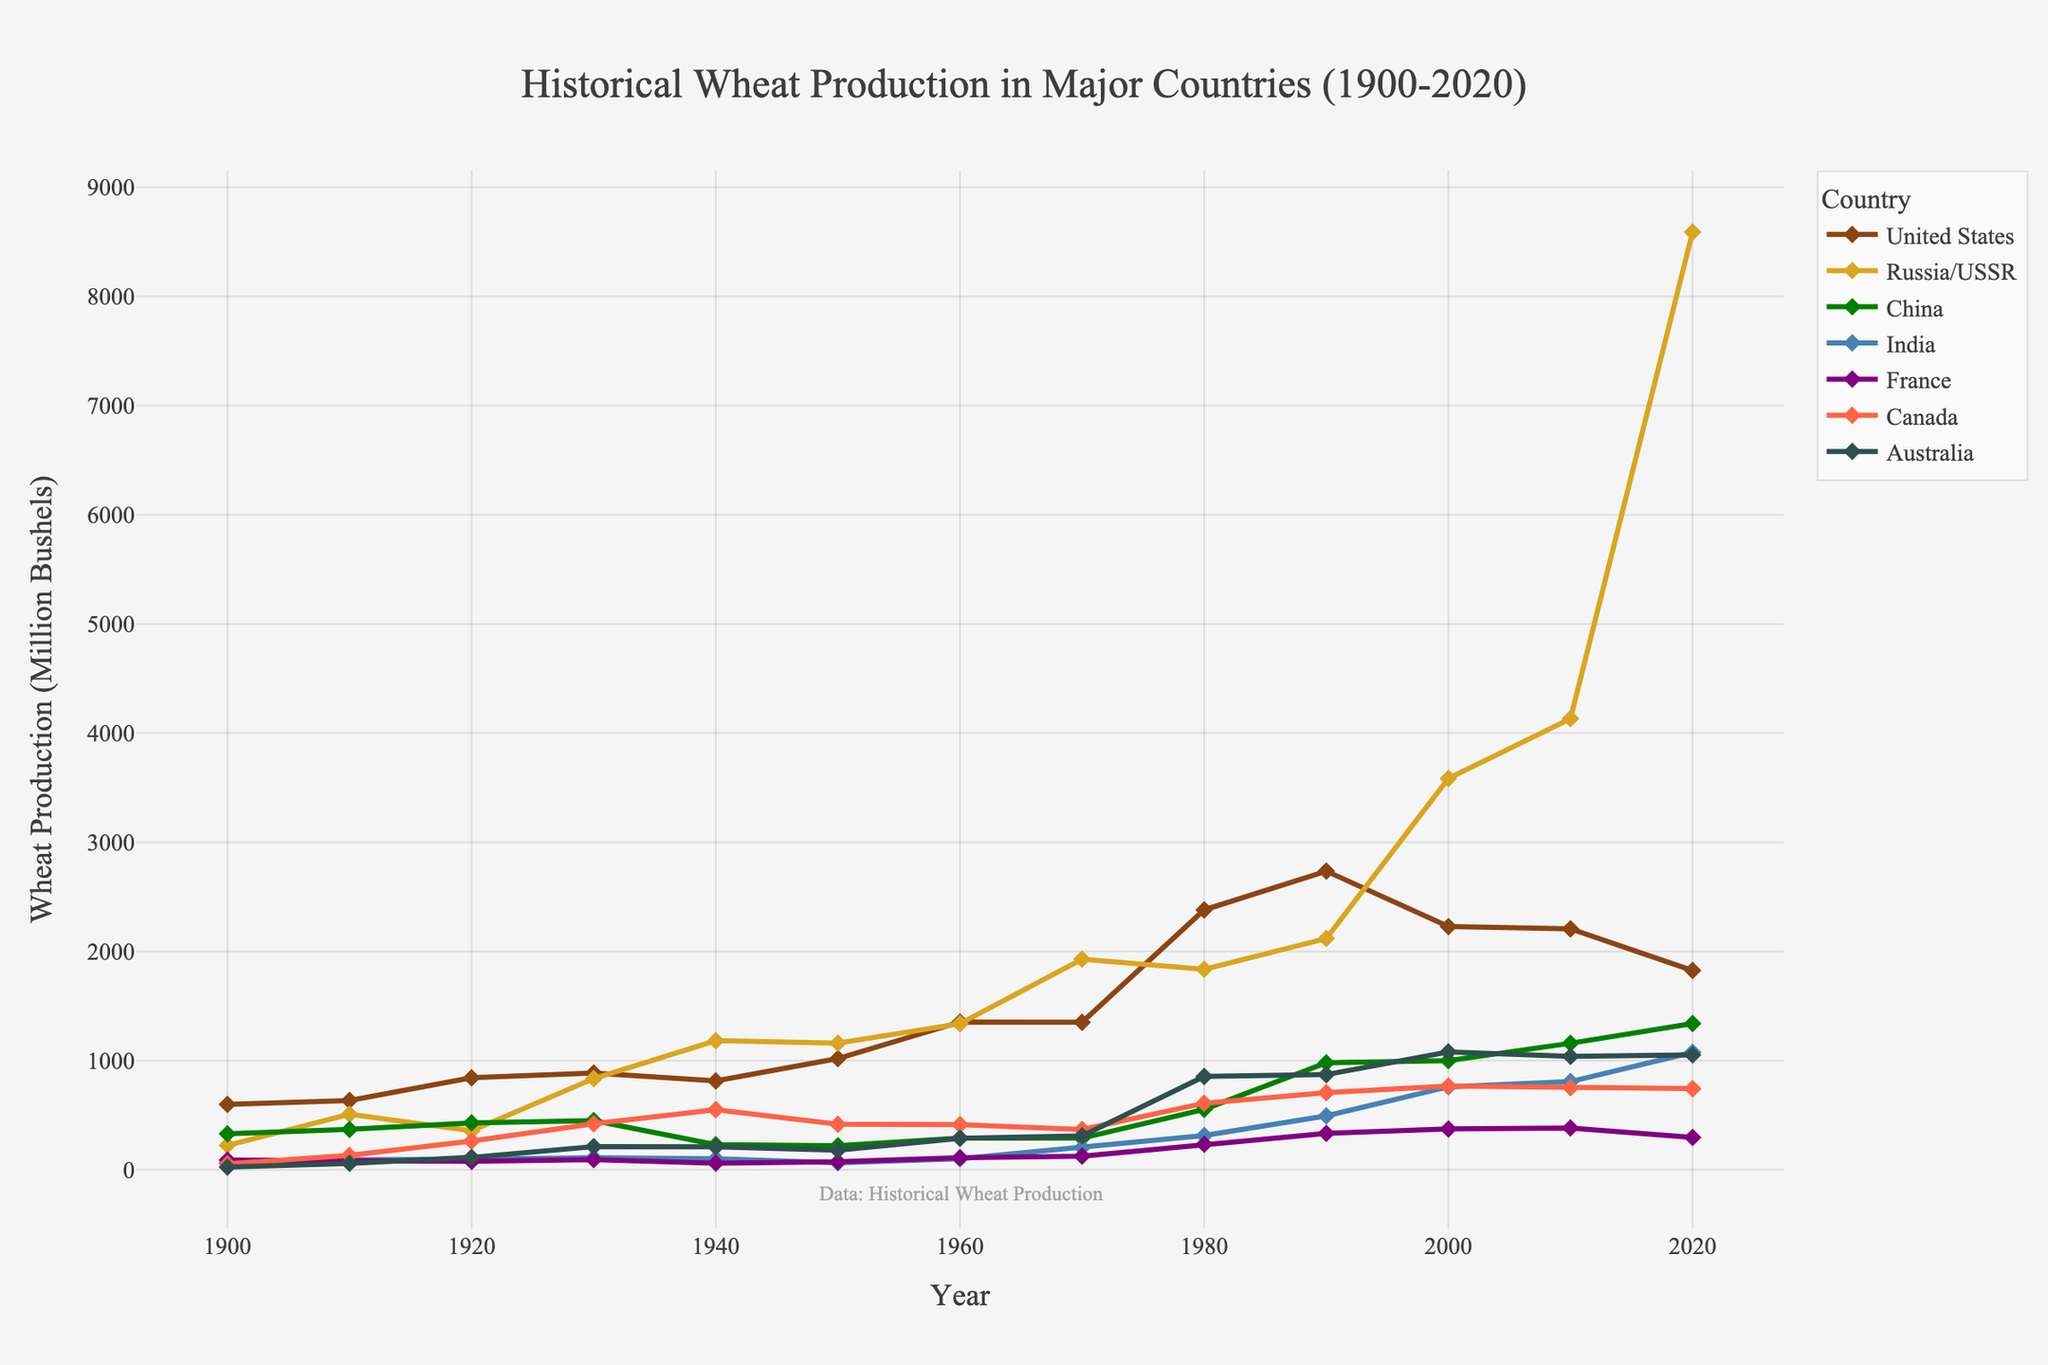- Which country had the highest wheat production in 2020? The figure shows the wheat production trends over the years. In 2020, by looking at the height of the lines, Russia/USSR's line reaches the highest value.
Answer: Russia/USSR - By how much did the United States' wheat production decrease from 1980 to 2020? The figure indicates that in 1980, the United States' wheat production was around 2381 million bushels, and in 2020, it was around 1826 million bushels. The difference can be calculated as 2381 - 1826.
Answer: 555 million bushels - Which country doubled its wheat production between 2000 and 2020? Referring to the chart, India’s production grows from around 760 million bushels in 2000 to around 1076 million bushels in 2020, clearly doubling the amount.
Answer: India - What was the production trend for China from 1900 to 2020? Observing the plot for China, its production started at 330 million bushels in 1900 and gradually increased to reach around 1340 million bushels by 2020, indicating an overall upward trend.
Answer: Upward trend - Comparing France and Canada, which country had higher wheat production in 1960? By examining the figure, in 1960, the production of France is represented by a shorter line in comparison to Canada’s line. Thus, Canada had higher production.
Answer: Canada - What was the average wheat production of France over the entire period? Summing all the given values for France (89, 87, 78, 94, 61, 73, 110, 125, 234, 333, 374, 383, 297) and dividing by the number of points (13 years), the average is (1774 / 13).
Answer: ~136 million bushels - How did Australia’s production in 1980 compare to that in 1970? According to the figure, Australia's production appeared to have more than doubled from 311 million bushels in 1970 to 855 million bushels in 1980.
Answer: It more than doubled - Which decade saw the highest increase in wheat production for the United States? From examining the chart, the steepest incline in the United States' wheat production occurred between 1950 and 1960. The increase was from 1019 to 1354 million bushels.
Answer: 1950-1960 - Who produced more wheat in 1940, Russia/USSR or China? Observing the 1940 data points, Russia/USSR (1183 million bushels) produced significantly more wheat than China (230 million bushels).
Answer: Russia/USSR - By how much did Russia/USSR's wheat production increase from 1990 to 2020? From the figure, the production in 1990 was around 2119 million bushels, and in 2020, it increased to 8590 million bushels. The increase can be calculated as 8590 - 2119.
Answer: 6471 million bushels 